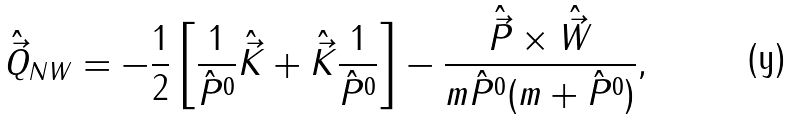<formula> <loc_0><loc_0><loc_500><loc_500>\hat { \vec { Q } } _ { N W } = - \frac { 1 } { 2 } \left [ \frac { 1 } { \hat { P } ^ { 0 } } \hat { \vec { K } } + \hat { \vec { K } } \frac { 1 } { \hat { P } ^ { 0 } } \right ] - \frac { \hat { \vec { P } } \times \hat { \vec { W } } } { m \hat { P } ^ { 0 } ( m + \hat { P } ^ { 0 } ) } ,</formula> 